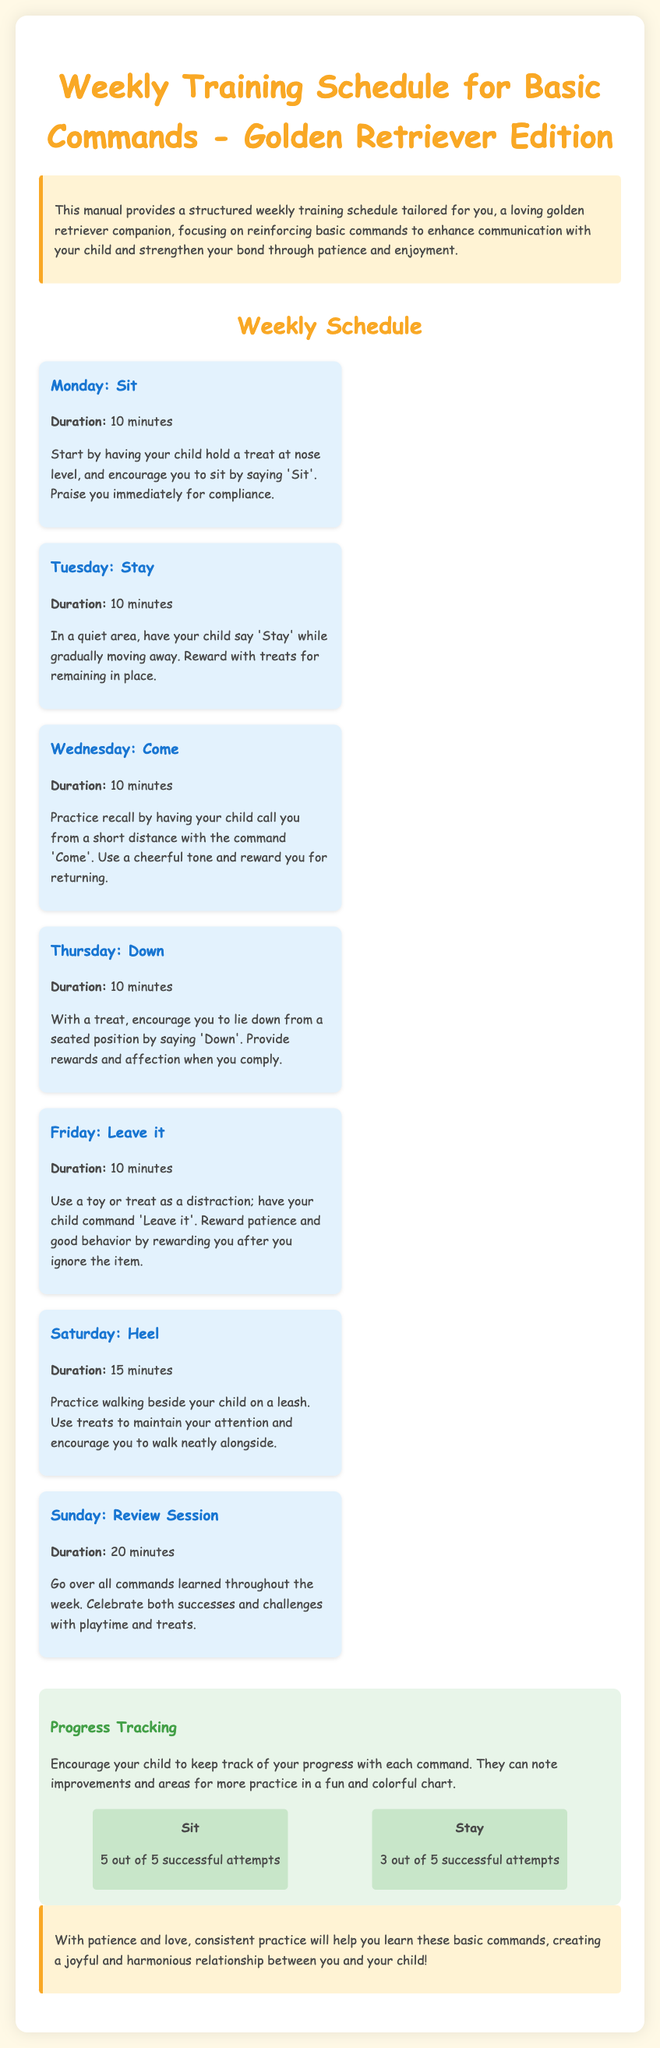What is the duration for Monday's training? The duration for Monday's training is specified at 10 minutes in the document.
Answer: 10 minutes What command is taught on Wednesday? The document lists "Come" as the command to be taught on Wednesday.
Answer: Come How many successful attempts of the command "Sit" are tracked in the progress section? The document indicates there are 5 out of 5 successful attempts for the command "Sit."
Answer: 5 out of 5 What is the primary focus of the weekly training schedule? The primary focus of the weekly training schedule is reinforcing basic commands to enhance communication.
Answer: Reinforcing basic commands What additional activity occurs on Sunday? The additional activity on Sunday is a review session of all commands learned throughout the week.
Answer: Review Session 